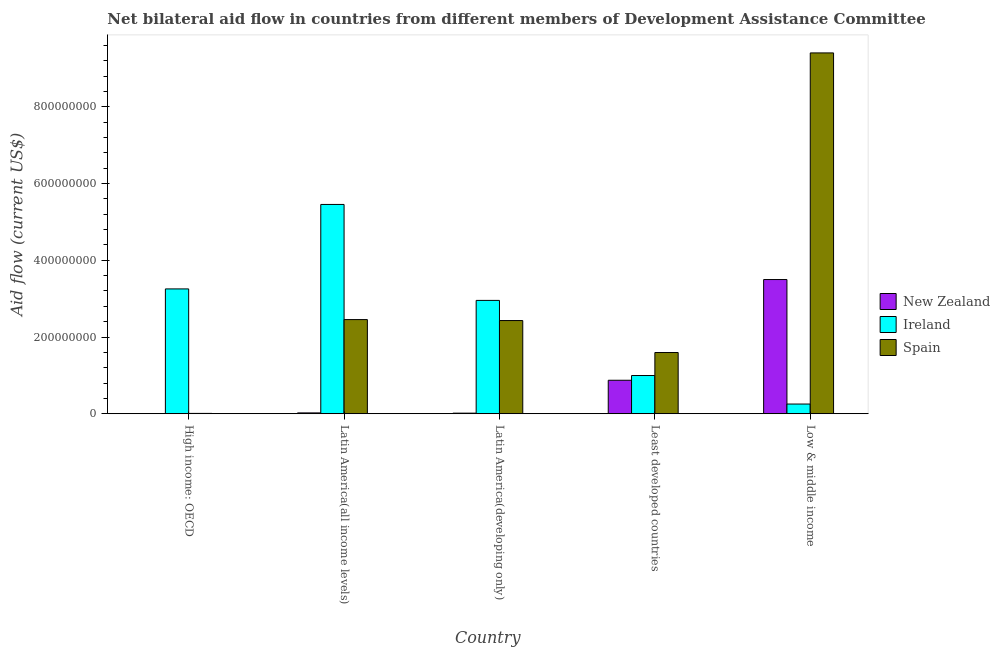How many groups of bars are there?
Ensure brevity in your answer.  5. Are the number of bars per tick equal to the number of legend labels?
Give a very brief answer. Yes. Are the number of bars on each tick of the X-axis equal?
Ensure brevity in your answer.  Yes. What is the label of the 1st group of bars from the left?
Your answer should be very brief. High income: OECD. In how many cases, is the number of bars for a given country not equal to the number of legend labels?
Give a very brief answer. 0. What is the amount of aid provided by spain in Latin America(all income levels)?
Make the answer very short. 2.45e+08. Across all countries, what is the maximum amount of aid provided by spain?
Make the answer very short. 9.41e+08. Across all countries, what is the minimum amount of aid provided by new zealand?
Make the answer very short. 4.30e+05. In which country was the amount of aid provided by spain maximum?
Ensure brevity in your answer.  Low & middle income. In which country was the amount of aid provided by spain minimum?
Your answer should be very brief. High income: OECD. What is the total amount of aid provided by ireland in the graph?
Give a very brief answer. 1.29e+09. What is the difference between the amount of aid provided by spain in Latin America(all income levels) and that in Least developed countries?
Provide a succinct answer. 8.59e+07. What is the difference between the amount of aid provided by ireland in Latin America(all income levels) and the amount of aid provided by spain in Low & middle income?
Give a very brief answer. -3.95e+08. What is the average amount of aid provided by ireland per country?
Make the answer very short. 2.58e+08. What is the difference between the amount of aid provided by spain and amount of aid provided by new zealand in Low & middle income?
Provide a succinct answer. 5.91e+08. In how many countries, is the amount of aid provided by ireland greater than 40000000 US$?
Ensure brevity in your answer.  4. What is the ratio of the amount of aid provided by new zealand in High income: OECD to that in Low & middle income?
Provide a succinct answer. 0. What is the difference between the highest and the second highest amount of aid provided by ireland?
Offer a very short reply. 2.20e+08. What is the difference between the highest and the lowest amount of aid provided by new zealand?
Your response must be concise. 3.49e+08. In how many countries, is the amount of aid provided by new zealand greater than the average amount of aid provided by new zealand taken over all countries?
Offer a terse response. 1. Is the sum of the amount of aid provided by ireland in Latin America(all income levels) and Latin America(developing only) greater than the maximum amount of aid provided by spain across all countries?
Make the answer very short. No. What does the 2nd bar from the left in Least developed countries represents?
Give a very brief answer. Ireland. What does the 2nd bar from the right in Latin America(all income levels) represents?
Ensure brevity in your answer.  Ireland. Is it the case that in every country, the sum of the amount of aid provided by new zealand and amount of aid provided by ireland is greater than the amount of aid provided by spain?
Keep it short and to the point. No. Are all the bars in the graph horizontal?
Ensure brevity in your answer.  No. What is the difference between two consecutive major ticks on the Y-axis?
Offer a very short reply. 2.00e+08. How many legend labels are there?
Keep it short and to the point. 3. What is the title of the graph?
Make the answer very short. Net bilateral aid flow in countries from different members of Development Assistance Committee. What is the label or title of the X-axis?
Your answer should be very brief. Country. What is the label or title of the Y-axis?
Offer a very short reply. Aid flow (current US$). What is the Aid flow (current US$) of Ireland in High income: OECD?
Offer a terse response. 3.25e+08. What is the Aid flow (current US$) of Spain in High income: OECD?
Your answer should be compact. 8.70e+05. What is the Aid flow (current US$) in New Zealand in Latin America(all income levels)?
Your answer should be compact. 2.21e+06. What is the Aid flow (current US$) of Ireland in Latin America(all income levels)?
Ensure brevity in your answer.  5.46e+08. What is the Aid flow (current US$) of Spain in Latin America(all income levels)?
Your answer should be compact. 2.45e+08. What is the Aid flow (current US$) in New Zealand in Latin America(developing only)?
Provide a short and direct response. 1.52e+06. What is the Aid flow (current US$) in Ireland in Latin America(developing only)?
Offer a terse response. 2.95e+08. What is the Aid flow (current US$) in Spain in Latin America(developing only)?
Make the answer very short. 2.43e+08. What is the Aid flow (current US$) in New Zealand in Least developed countries?
Ensure brevity in your answer.  8.73e+07. What is the Aid flow (current US$) in Ireland in Least developed countries?
Give a very brief answer. 9.96e+07. What is the Aid flow (current US$) in Spain in Least developed countries?
Ensure brevity in your answer.  1.60e+08. What is the Aid flow (current US$) of New Zealand in Low & middle income?
Your response must be concise. 3.50e+08. What is the Aid flow (current US$) of Ireland in Low & middle income?
Your answer should be compact. 2.53e+07. What is the Aid flow (current US$) in Spain in Low & middle income?
Ensure brevity in your answer.  9.41e+08. Across all countries, what is the maximum Aid flow (current US$) in New Zealand?
Your answer should be compact. 3.50e+08. Across all countries, what is the maximum Aid flow (current US$) of Ireland?
Keep it short and to the point. 5.46e+08. Across all countries, what is the maximum Aid flow (current US$) of Spain?
Make the answer very short. 9.41e+08. Across all countries, what is the minimum Aid flow (current US$) of New Zealand?
Make the answer very short. 4.30e+05. Across all countries, what is the minimum Aid flow (current US$) in Ireland?
Keep it short and to the point. 2.53e+07. Across all countries, what is the minimum Aid flow (current US$) of Spain?
Your answer should be compact. 8.70e+05. What is the total Aid flow (current US$) of New Zealand in the graph?
Keep it short and to the point. 4.41e+08. What is the total Aid flow (current US$) of Ireland in the graph?
Give a very brief answer. 1.29e+09. What is the total Aid flow (current US$) of Spain in the graph?
Make the answer very short. 1.59e+09. What is the difference between the Aid flow (current US$) in New Zealand in High income: OECD and that in Latin America(all income levels)?
Your response must be concise. -1.78e+06. What is the difference between the Aid flow (current US$) of Ireland in High income: OECD and that in Latin America(all income levels)?
Provide a succinct answer. -2.20e+08. What is the difference between the Aid flow (current US$) of Spain in High income: OECD and that in Latin America(all income levels)?
Keep it short and to the point. -2.45e+08. What is the difference between the Aid flow (current US$) of New Zealand in High income: OECD and that in Latin America(developing only)?
Give a very brief answer. -1.09e+06. What is the difference between the Aid flow (current US$) of Ireland in High income: OECD and that in Latin America(developing only)?
Provide a short and direct response. 2.99e+07. What is the difference between the Aid flow (current US$) of Spain in High income: OECD and that in Latin America(developing only)?
Keep it short and to the point. -2.42e+08. What is the difference between the Aid flow (current US$) of New Zealand in High income: OECD and that in Least developed countries?
Your answer should be compact. -8.68e+07. What is the difference between the Aid flow (current US$) of Ireland in High income: OECD and that in Least developed countries?
Offer a very short reply. 2.26e+08. What is the difference between the Aid flow (current US$) of Spain in High income: OECD and that in Least developed countries?
Your answer should be very brief. -1.59e+08. What is the difference between the Aid flow (current US$) in New Zealand in High income: OECD and that in Low & middle income?
Your response must be concise. -3.49e+08. What is the difference between the Aid flow (current US$) of Ireland in High income: OECD and that in Low & middle income?
Make the answer very short. 3.00e+08. What is the difference between the Aid flow (current US$) in Spain in High income: OECD and that in Low & middle income?
Your response must be concise. -9.40e+08. What is the difference between the Aid flow (current US$) in New Zealand in Latin America(all income levels) and that in Latin America(developing only)?
Offer a very short reply. 6.90e+05. What is the difference between the Aid flow (current US$) in Ireland in Latin America(all income levels) and that in Latin America(developing only)?
Ensure brevity in your answer.  2.50e+08. What is the difference between the Aid flow (current US$) in Spain in Latin America(all income levels) and that in Latin America(developing only)?
Your answer should be compact. 2.53e+06. What is the difference between the Aid flow (current US$) of New Zealand in Latin America(all income levels) and that in Least developed countries?
Your response must be concise. -8.51e+07. What is the difference between the Aid flow (current US$) in Ireland in Latin America(all income levels) and that in Least developed countries?
Your response must be concise. 4.46e+08. What is the difference between the Aid flow (current US$) of Spain in Latin America(all income levels) and that in Least developed countries?
Offer a terse response. 8.59e+07. What is the difference between the Aid flow (current US$) in New Zealand in Latin America(all income levels) and that in Low & middle income?
Your answer should be compact. -3.48e+08. What is the difference between the Aid flow (current US$) in Ireland in Latin America(all income levels) and that in Low & middle income?
Ensure brevity in your answer.  5.20e+08. What is the difference between the Aid flow (current US$) in Spain in Latin America(all income levels) and that in Low & middle income?
Offer a terse response. -6.95e+08. What is the difference between the Aid flow (current US$) of New Zealand in Latin America(developing only) and that in Least developed countries?
Your response must be concise. -8.58e+07. What is the difference between the Aid flow (current US$) in Ireland in Latin America(developing only) and that in Least developed countries?
Your answer should be compact. 1.96e+08. What is the difference between the Aid flow (current US$) of Spain in Latin America(developing only) and that in Least developed countries?
Your answer should be very brief. 8.33e+07. What is the difference between the Aid flow (current US$) of New Zealand in Latin America(developing only) and that in Low & middle income?
Offer a very short reply. -3.48e+08. What is the difference between the Aid flow (current US$) of Ireland in Latin America(developing only) and that in Low & middle income?
Make the answer very short. 2.70e+08. What is the difference between the Aid flow (current US$) of Spain in Latin America(developing only) and that in Low & middle income?
Provide a short and direct response. -6.98e+08. What is the difference between the Aid flow (current US$) in New Zealand in Least developed countries and that in Low & middle income?
Give a very brief answer. -2.63e+08. What is the difference between the Aid flow (current US$) of Ireland in Least developed countries and that in Low & middle income?
Keep it short and to the point. 7.44e+07. What is the difference between the Aid flow (current US$) of Spain in Least developed countries and that in Low & middle income?
Provide a short and direct response. -7.81e+08. What is the difference between the Aid flow (current US$) of New Zealand in High income: OECD and the Aid flow (current US$) of Ireland in Latin America(all income levels)?
Provide a succinct answer. -5.45e+08. What is the difference between the Aid flow (current US$) in New Zealand in High income: OECD and the Aid flow (current US$) in Spain in Latin America(all income levels)?
Make the answer very short. -2.45e+08. What is the difference between the Aid flow (current US$) in Ireland in High income: OECD and the Aid flow (current US$) in Spain in Latin America(all income levels)?
Offer a very short reply. 8.00e+07. What is the difference between the Aid flow (current US$) in New Zealand in High income: OECD and the Aid flow (current US$) in Ireland in Latin America(developing only)?
Offer a terse response. -2.95e+08. What is the difference between the Aid flow (current US$) in New Zealand in High income: OECD and the Aid flow (current US$) in Spain in Latin America(developing only)?
Provide a succinct answer. -2.42e+08. What is the difference between the Aid flow (current US$) of Ireland in High income: OECD and the Aid flow (current US$) of Spain in Latin America(developing only)?
Your answer should be very brief. 8.25e+07. What is the difference between the Aid flow (current US$) of New Zealand in High income: OECD and the Aid flow (current US$) of Ireland in Least developed countries?
Provide a short and direct response. -9.92e+07. What is the difference between the Aid flow (current US$) in New Zealand in High income: OECD and the Aid flow (current US$) in Spain in Least developed countries?
Keep it short and to the point. -1.59e+08. What is the difference between the Aid flow (current US$) in Ireland in High income: OECD and the Aid flow (current US$) in Spain in Least developed countries?
Make the answer very short. 1.66e+08. What is the difference between the Aid flow (current US$) in New Zealand in High income: OECD and the Aid flow (current US$) in Ireland in Low & middle income?
Provide a succinct answer. -2.48e+07. What is the difference between the Aid flow (current US$) in New Zealand in High income: OECD and the Aid flow (current US$) in Spain in Low & middle income?
Offer a very short reply. -9.40e+08. What is the difference between the Aid flow (current US$) of Ireland in High income: OECD and the Aid flow (current US$) of Spain in Low & middle income?
Give a very brief answer. -6.15e+08. What is the difference between the Aid flow (current US$) in New Zealand in Latin America(all income levels) and the Aid flow (current US$) in Ireland in Latin America(developing only)?
Keep it short and to the point. -2.93e+08. What is the difference between the Aid flow (current US$) of New Zealand in Latin America(all income levels) and the Aid flow (current US$) of Spain in Latin America(developing only)?
Give a very brief answer. -2.41e+08. What is the difference between the Aid flow (current US$) in Ireland in Latin America(all income levels) and the Aid flow (current US$) in Spain in Latin America(developing only)?
Ensure brevity in your answer.  3.03e+08. What is the difference between the Aid flow (current US$) of New Zealand in Latin America(all income levels) and the Aid flow (current US$) of Ireland in Least developed countries?
Offer a very short reply. -9.74e+07. What is the difference between the Aid flow (current US$) of New Zealand in Latin America(all income levels) and the Aid flow (current US$) of Spain in Least developed countries?
Your answer should be very brief. -1.57e+08. What is the difference between the Aid flow (current US$) of Ireland in Latin America(all income levels) and the Aid flow (current US$) of Spain in Least developed countries?
Provide a succinct answer. 3.86e+08. What is the difference between the Aid flow (current US$) of New Zealand in Latin America(all income levels) and the Aid flow (current US$) of Ireland in Low & middle income?
Offer a terse response. -2.31e+07. What is the difference between the Aid flow (current US$) of New Zealand in Latin America(all income levels) and the Aid flow (current US$) of Spain in Low & middle income?
Give a very brief answer. -9.38e+08. What is the difference between the Aid flow (current US$) in Ireland in Latin America(all income levels) and the Aid flow (current US$) in Spain in Low & middle income?
Provide a short and direct response. -3.95e+08. What is the difference between the Aid flow (current US$) in New Zealand in Latin America(developing only) and the Aid flow (current US$) in Ireland in Least developed countries?
Give a very brief answer. -9.81e+07. What is the difference between the Aid flow (current US$) of New Zealand in Latin America(developing only) and the Aid flow (current US$) of Spain in Least developed countries?
Keep it short and to the point. -1.58e+08. What is the difference between the Aid flow (current US$) in Ireland in Latin America(developing only) and the Aid flow (current US$) in Spain in Least developed countries?
Provide a short and direct response. 1.36e+08. What is the difference between the Aid flow (current US$) of New Zealand in Latin America(developing only) and the Aid flow (current US$) of Ireland in Low & middle income?
Offer a terse response. -2.38e+07. What is the difference between the Aid flow (current US$) of New Zealand in Latin America(developing only) and the Aid flow (current US$) of Spain in Low & middle income?
Offer a very short reply. -9.39e+08. What is the difference between the Aid flow (current US$) in Ireland in Latin America(developing only) and the Aid flow (current US$) in Spain in Low & middle income?
Your answer should be very brief. -6.45e+08. What is the difference between the Aid flow (current US$) in New Zealand in Least developed countries and the Aid flow (current US$) in Ireland in Low & middle income?
Offer a terse response. 6.20e+07. What is the difference between the Aid flow (current US$) of New Zealand in Least developed countries and the Aid flow (current US$) of Spain in Low & middle income?
Your answer should be compact. -8.53e+08. What is the difference between the Aid flow (current US$) of Ireland in Least developed countries and the Aid flow (current US$) of Spain in Low & middle income?
Your answer should be compact. -8.41e+08. What is the average Aid flow (current US$) in New Zealand per country?
Provide a short and direct response. 8.83e+07. What is the average Aid flow (current US$) of Ireland per country?
Provide a succinct answer. 2.58e+08. What is the average Aid flow (current US$) of Spain per country?
Ensure brevity in your answer.  3.18e+08. What is the difference between the Aid flow (current US$) of New Zealand and Aid flow (current US$) of Ireland in High income: OECD?
Ensure brevity in your answer.  -3.25e+08. What is the difference between the Aid flow (current US$) of New Zealand and Aid flow (current US$) of Spain in High income: OECD?
Give a very brief answer. -4.40e+05. What is the difference between the Aid flow (current US$) of Ireland and Aid flow (current US$) of Spain in High income: OECD?
Offer a very short reply. 3.25e+08. What is the difference between the Aid flow (current US$) of New Zealand and Aid flow (current US$) of Ireland in Latin America(all income levels)?
Offer a terse response. -5.43e+08. What is the difference between the Aid flow (current US$) of New Zealand and Aid flow (current US$) of Spain in Latin America(all income levels)?
Provide a succinct answer. -2.43e+08. What is the difference between the Aid flow (current US$) in Ireland and Aid flow (current US$) in Spain in Latin America(all income levels)?
Your response must be concise. 3.00e+08. What is the difference between the Aid flow (current US$) of New Zealand and Aid flow (current US$) of Ireland in Latin America(developing only)?
Your response must be concise. -2.94e+08. What is the difference between the Aid flow (current US$) of New Zealand and Aid flow (current US$) of Spain in Latin America(developing only)?
Your response must be concise. -2.41e+08. What is the difference between the Aid flow (current US$) of Ireland and Aid flow (current US$) of Spain in Latin America(developing only)?
Offer a very short reply. 5.26e+07. What is the difference between the Aid flow (current US$) of New Zealand and Aid flow (current US$) of Ireland in Least developed countries?
Offer a terse response. -1.24e+07. What is the difference between the Aid flow (current US$) in New Zealand and Aid flow (current US$) in Spain in Least developed countries?
Ensure brevity in your answer.  -7.23e+07. What is the difference between the Aid flow (current US$) of Ireland and Aid flow (current US$) of Spain in Least developed countries?
Your answer should be compact. -6.00e+07. What is the difference between the Aid flow (current US$) in New Zealand and Aid flow (current US$) in Ireland in Low & middle income?
Offer a very short reply. 3.25e+08. What is the difference between the Aid flow (current US$) of New Zealand and Aid flow (current US$) of Spain in Low & middle income?
Give a very brief answer. -5.91e+08. What is the difference between the Aid flow (current US$) of Ireland and Aid flow (current US$) of Spain in Low & middle income?
Make the answer very short. -9.15e+08. What is the ratio of the Aid flow (current US$) of New Zealand in High income: OECD to that in Latin America(all income levels)?
Ensure brevity in your answer.  0.19. What is the ratio of the Aid flow (current US$) in Ireland in High income: OECD to that in Latin America(all income levels)?
Your response must be concise. 0.6. What is the ratio of the Aid flow (current US$) of Spain in High income: OECD to that in Latin America(all income levels)?
Your response must be concise. 0. What is the ratio of the Aid flow (current US$) in New Zealand in High income: OECD to that in Latin America(developing only)?
Your answer should be compact. 0.28. What is the ratio of the Aid flow (current US$) of Ireland in High income: OECD to that in Latin America(developing only)?
Provide a short and direct response. 1.1. What is the ratio of the Aid flow (current US$) in Spain in High income: OECD to that in Latin America(developing only)?
Make the answer very short. 0. What is the ratio of the Aid flow (current US$) in New Zealand in High income: OECD to that in Least developed countries?
Provide a short and direct response. 0. What is the ratio of the Aid flow (current US$) in Ireland in High income: OECD to that in Least developed countries?
Offer a terse response. 3.27. What is the ratio of the Aid flow (current US$) in Spain in High income: OECD to that in Least developed countries?
Provide a short and direct response. 0.01. What is the ratio of the Aid flow (current US$) of New Zealand in High income: OECD to that in Low & middle income?
Ensure brevity in your answer.  0. What is the ratio of the Aid flow (current US$) of Ireland in High income: OECD to that in Low & middle income?
Your response must be concise. 12.88. What is the ratio of the Aid flow (current US$) of Spain in High income: OECD to that in Low & middle income?
Your response must be concise. 0. What is the ratio of the Aid flow (current US$) of New Zealand in Latin America(all income levels) to that in Latin America(developing only)?
Keep it short and to the point. 1.45. What is the ratio of the Aid flow (current US$) of Ireland in Latin America(all income levels) to that in Latin America(developing only)?
Provide a succinct answer. 1.85. What is the ratio of the Aid flow (current US$) in Spain in Latin America(all income levels) to that in Latin America(developing only)?
Offer a very short reply. 1.01. What is the ratio of the Aid flow (current US$) of New Zealand in Latin America(all income levels) to that in Least developed countries?
Provide a short and direct response. 0.03. What is the ratio of the Aid flow (current US$) of Ireland in Latin America(all income levels) to that in Least developed countries?
Your response must be concise. 5.48. What is the ratio of the Aid flow (current US$) in Spain in Latin America(all income levels) to that in Least developed countries?
Offer a very short reply. 1.54. What is the ratio of the Aid flow (current US$) in New Zealand in Latin America(all income levels) to that in Low & middle income?
Keep it short and to the point. 0.01. What is the ratio of the Aid flow (current US$) of Ireland in Latin America(all income levels) to that in Low & middle income?
Give a very brief answer. 21.59. What is the ratio of the Aid flow (current US$) in Spain in Latin America(all income levels) to that in Low & middle income?
Provide a short and direct response. 0.26. What is the ratio of the Aid flow (current US$) of New Zealand in Latin America(developing only) to that in Least developed countries?
Offer a very short reply. 0.02. What is the ratio of the Aid flow (current US$) in Ireland in Latin America(developing only) to that in Least developed countries?
Offer a terse response. 2.97. What is the ratio of the Aid flow (current US$) in Spain in Latin America(developing only) to that in Least developed countries?
Give a very brief answer. 1.52. What is the ratio of the Aid flow (current US$) in New Zealand in Latin America(developing only) to that in Low & middle income?
Make the answer very short. 0. What is the ratio of the Aid flow (current US$) of Ireland in Latin America(developing only) to that in Low & middle income?
Your answer should be compact. 11.69. What is the ratio of the Aid flow (current US$) of Spain in Latin America(developing only) to that in Low & middle income?
Provide a short and direct response. 0.26. What is the ratio of the Aid flow (current US$) in New Zealand in Least developed countries to that in Low & middle income?
Provide a succinct answer. 0.25. What is the ratio of the Aid flow (current US$) in Ireland in Least developed countries to that in Low & middle income?
Keep it short and to the point. 3.94. What is the ratio of the Aid flow (current US$) in Spain in Least developed countries to that in Low & middle income?
Offer a terse response. 0.17. What is the difference between the highest and the second highest Aid flow (current US$) of New Zealand?
Offer a very short reply. 2.63e+08. What is the difference between the highest and the second highest Aid flow (current US$) of Ireland?
Ensure brevity in your answer.  2.20e+08. What is the difference between the highest and the second highest Aid flow (current US$) in Spain?
Make the answer very short. 6.95e+08. What is the difference between the highest and the lowest Aid flow (current US$) in New Zealand?
Your answer should be compact. 3.49e+08. What is the difference between the highest and the lowest Aid flow (current US$) of Ireland?
Your answer should be compact. 5.20e+08. What is the difference between the highest and the lowest Aid flow (current US$) in Spain?
Your answer should be very brief. 9.40e+08. 